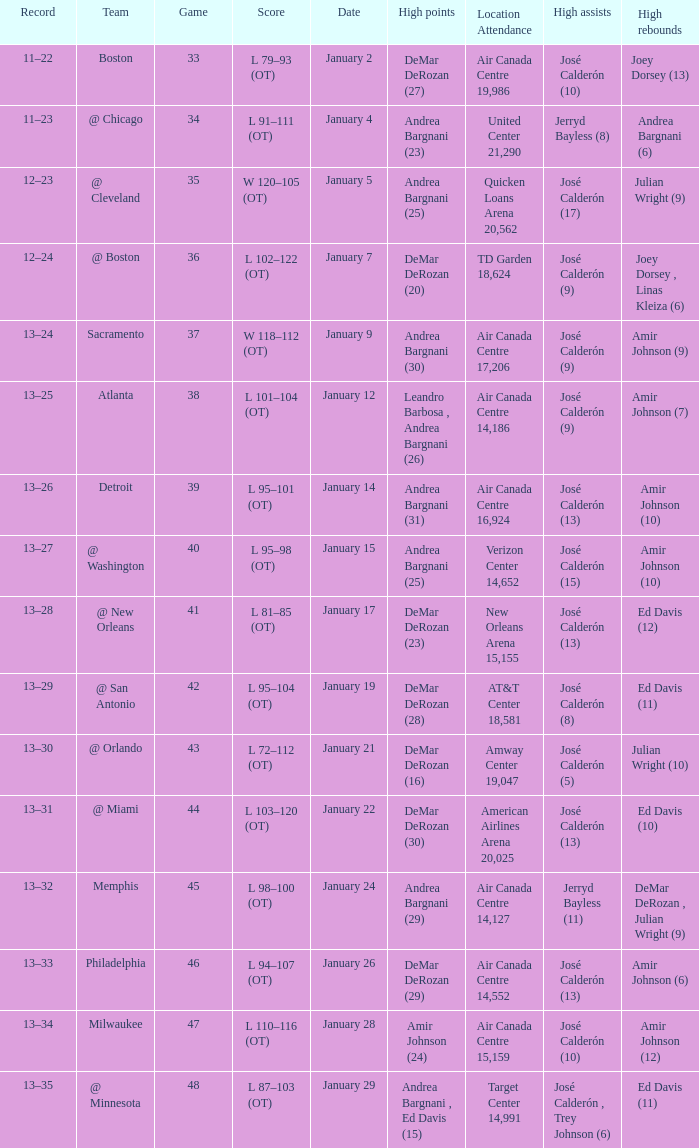Name the team for score l 102–122 (ot) @ Boston. 